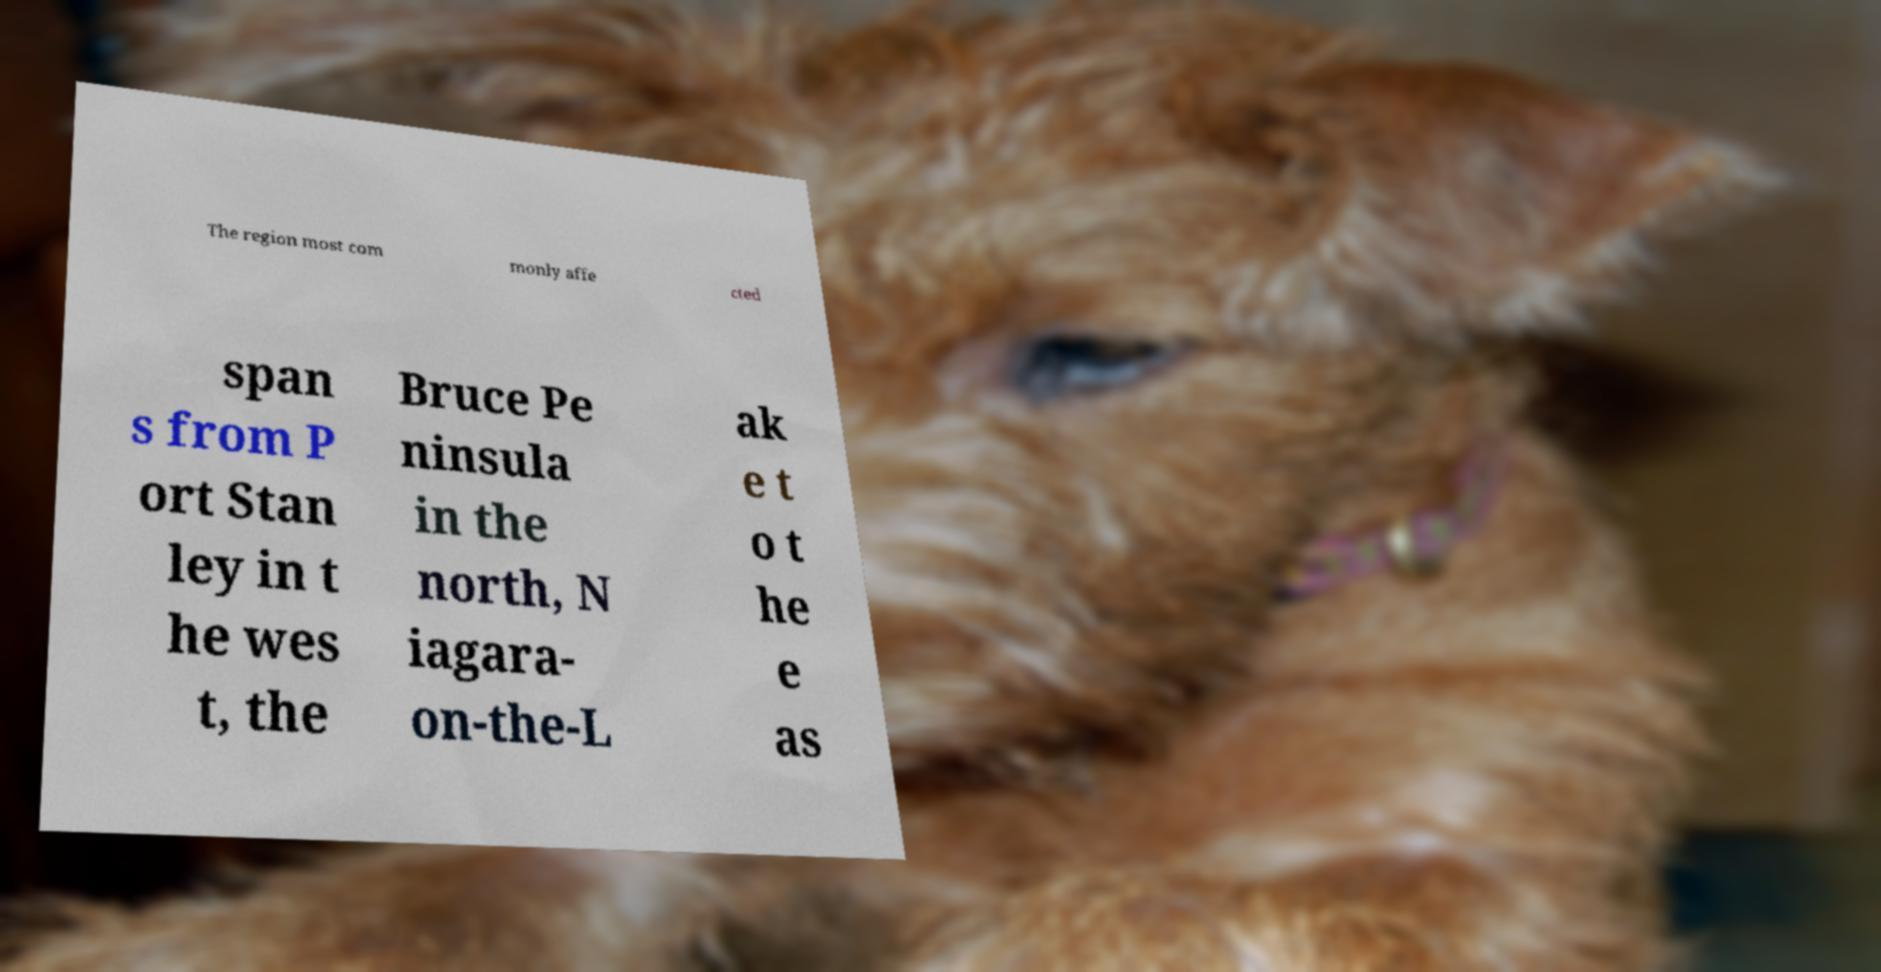There's text embedded in this image that I need extracted. Can you transcribe it verbatim? The region most com monly affe cted span s from P ort Stan ley in t he wes t, the Bruce Pe ninsula in the north, N iagara- on-the-L ak e t o t he e as 